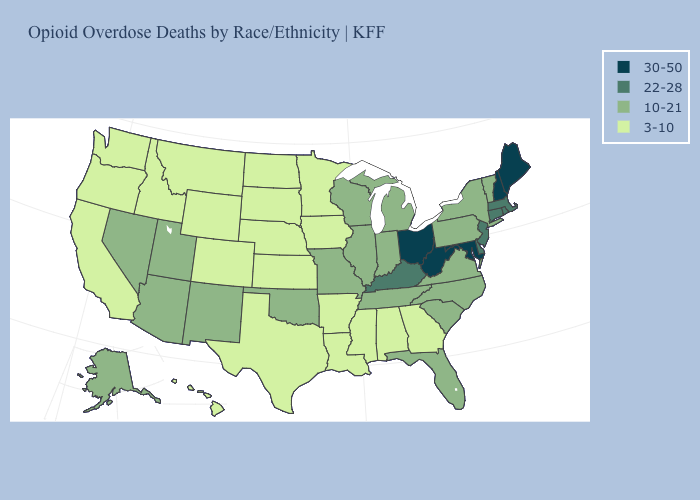Does Maine have the highest value in the Northeast?
Keep it brief. Yes. Which states have the lowest value in the USA?
Keep it brief. Alabama, Arkansas, California, Colorado, Georgia, Hawaii, Idaho, Iowa, Kansas, Louisiana, Minnesota, Mississippi, Montana, Nebraska, North Dakota, Oregon, South Dakota, Texas, Washington, Wyoming. Does the first symbol in the legend represent the smallest category?
Answer briefly. No. Does Ohio have the highest value in the MidWest?
Short answer required. Yes. Does Nebraska have the same value as Hawaii?
Keep it brief. Yes. Name the states that have a value in the range 30-50?
Write a very short answer. Maine, Maryland, New Hampshire, Ohio, West Virginia. What is the value of Montana?
Short answer required. 3-10. Name the states that have a value in the range 30-50?
Answer briefly. Maine, Maryland, New Hampshire, Ohio, West Virginia. What is the lowest value in the USA?
Quick response, please. 3-10. What is the value of Texas?
Keep it brief. 3-10. What is the value of Utah?
Give a very brief answer. 10-21. Which states have the lowest value in the MidWest?
Give a very brief answer. Iowa, Kansas, Minnesota, Nebraska, North Dakota, South Dakota. What is the lowest value in the USA?
Be succinct. 3-10. How many symbols are there in the legend?
Keep it brief. 4. Name the states that have a value in the range 3-10?
Answer briefly. Alabama, Arkansas, California, Colorado, Georgia, Hawaii, Idaho, Iowa, Kansas, Louisiana, Minnesota, Mississippi, Montana, Nebraska, North Dakota, Oregon, South Dakota, Texas, Washington, Wyoming. 